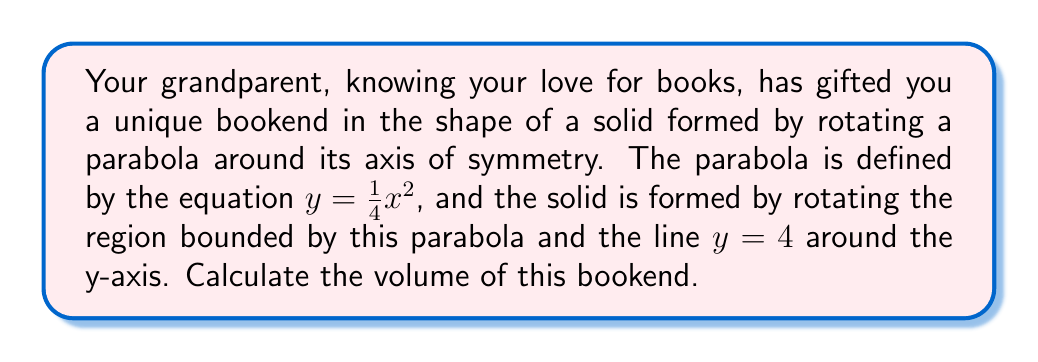Teach me how to tackle this problem. Let's approach this step-by-step:

1) The volume of a solid formed by rotating a region around the y-axis is given by the formula:

   $$V = \pi \int_a^b [f(y)]^2 dy$$

   where $f(y)$ is the function that describes the boundary of the region in terms of y.

2) In this case, we need to express x in terms of y. From the given equation:

   $y = \frac{1}{4}x^2$
   $x^2 = 4y$
   $x = \pm 2\sqrt{y}$

3) Since we're rotating around the y-axis, we only need the positive value:

   $x = 2\sqrt{y}$

4) The limits of integration are from $y = 0$ (the vertex of the parabola) to $y = 4$ (the given upper bound).

5) Now we can set up our integral:

   $$V = \pi \int_0^4 (2\sqrt{y})^2 dy$$

6) Simplify:

   $$V = \pi \int_0^4 4y dy$$

7) Integrate:

   $$V = \pi [4 \cdot \frac{y^2}{2}]_0^4$$

8) Evaluate the limits:

   $$V = \pi [4 \cdot \frac{4^2}{2} - 4 \cdot \frac{0^2}{2}]$$
   $$V = \pi [4 \cdot 8 - 0]$$
   $$V = 32\pi$$

Therefore, the volume of the bookend is $32\pi$ cubic units.

[asy]
import graph;
size(200,200);
real f(real x) {return x^2/4;}
path p=graph(f,-4,4);
fill((-4,0)--(4,0)--(4,4)--(-4,4)--cycle,lightgray);
fill((0,0)--(4,0)--p--(0,4)--cycle,white);
draw(p);
draw((0,0)--(0,4),arrow=Arrow(TeXHead));
draw((-4,0)--(4,0),arrow=Arrow(TeXHead));
draw((0,4)--(4,4),dashed);
label("$y=4$",(4.2,4),E);
label("$y=\frac{1}{4}x^2$",(3,2),E);
[/asy]
Answer: $32\pi$ cubic units 